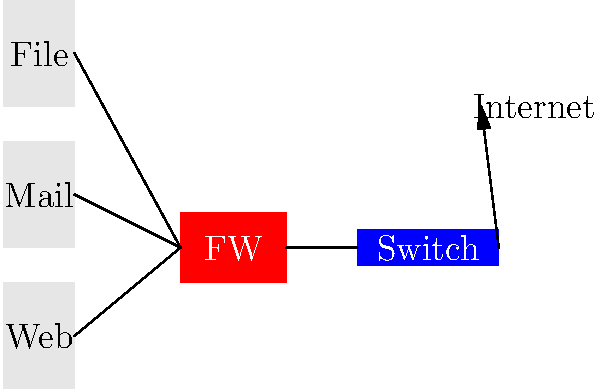In the given network diagram for a small business, which component should be placed between the internal network and the Internet to provide basic security? To design a basic firewall setup for a small business network, we need to understand the key components and their roles:

1. Internal network: This includes the web server, mail server, and file server, which contain sensitive business data and services.

2. Switch: This device connects the internal servers and facilitates communication between them.

3. Firewall: This is the critical security component that should be placed between the internal network and the Internet.

4. Internet: This represents the external network and potential security threats.

The firewall serves several important functions:

a) It acts as a barrier between the trusted internal network and untrusted external networks (like the Internet).

b) It monitors and controls incoming and outgoing network traffic based on predetermined security rules.

c) It can protect against various types of cyber attacks, such as DDoS, malware, and unauthorized access attempts.

d) It can log network activity for security analysis and auditing purposes.

In the diagram, the firewall (FW) is correctly placed between the internal switch and the Internet connection. This positioning allows it to inspect all traffic entering or leaving the internal network, providing a basic level of security for the small business's IT infrastructure.
Answer: Firewall 